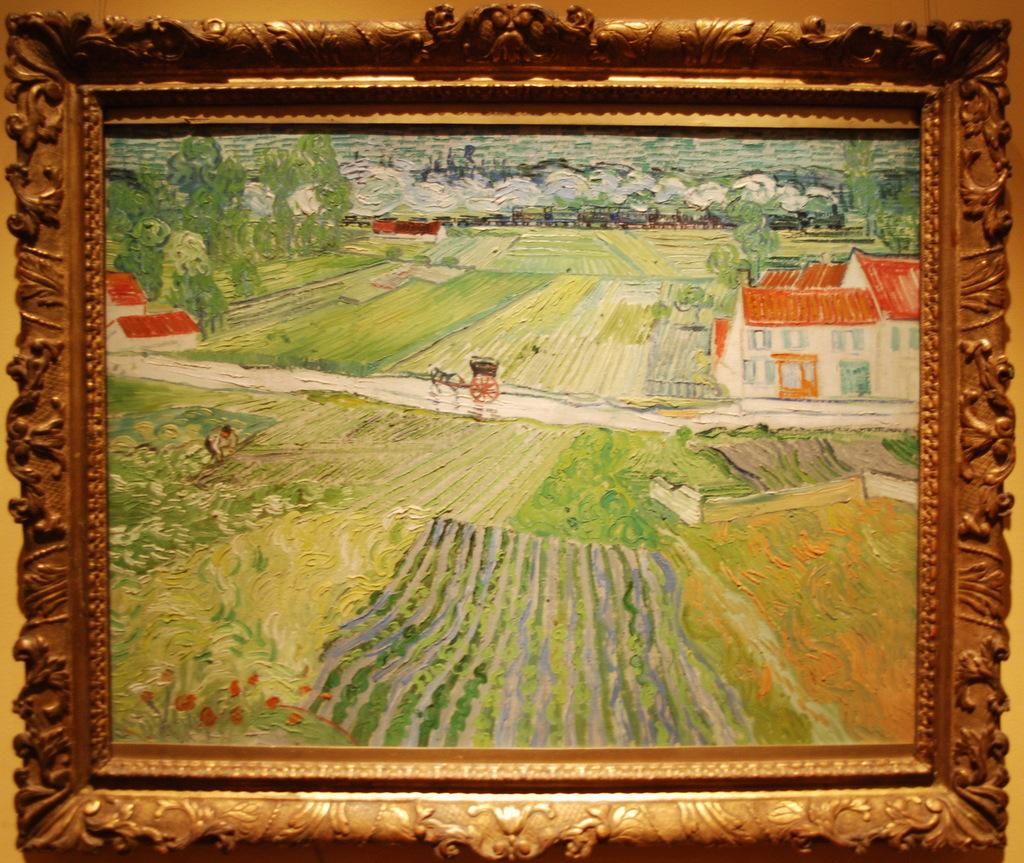What object is on the platform in the image? There is a photo frame on the platform. What is depicted in the photo? The photo contains a painting of fields. What elements are included in the painting? The painting includes houses, a horse cart on a path, and trees. Are there any people in the painting? Yes, there is a person on the left side of the painting. What type of science experiment is being conducted in the painting? There is no science experiment present in the painting; it depicts a scene of fields, houses, a horse cart, trees, and a person. How many chickens can be seen in the painting? There are no chickens depicted in the painting. 